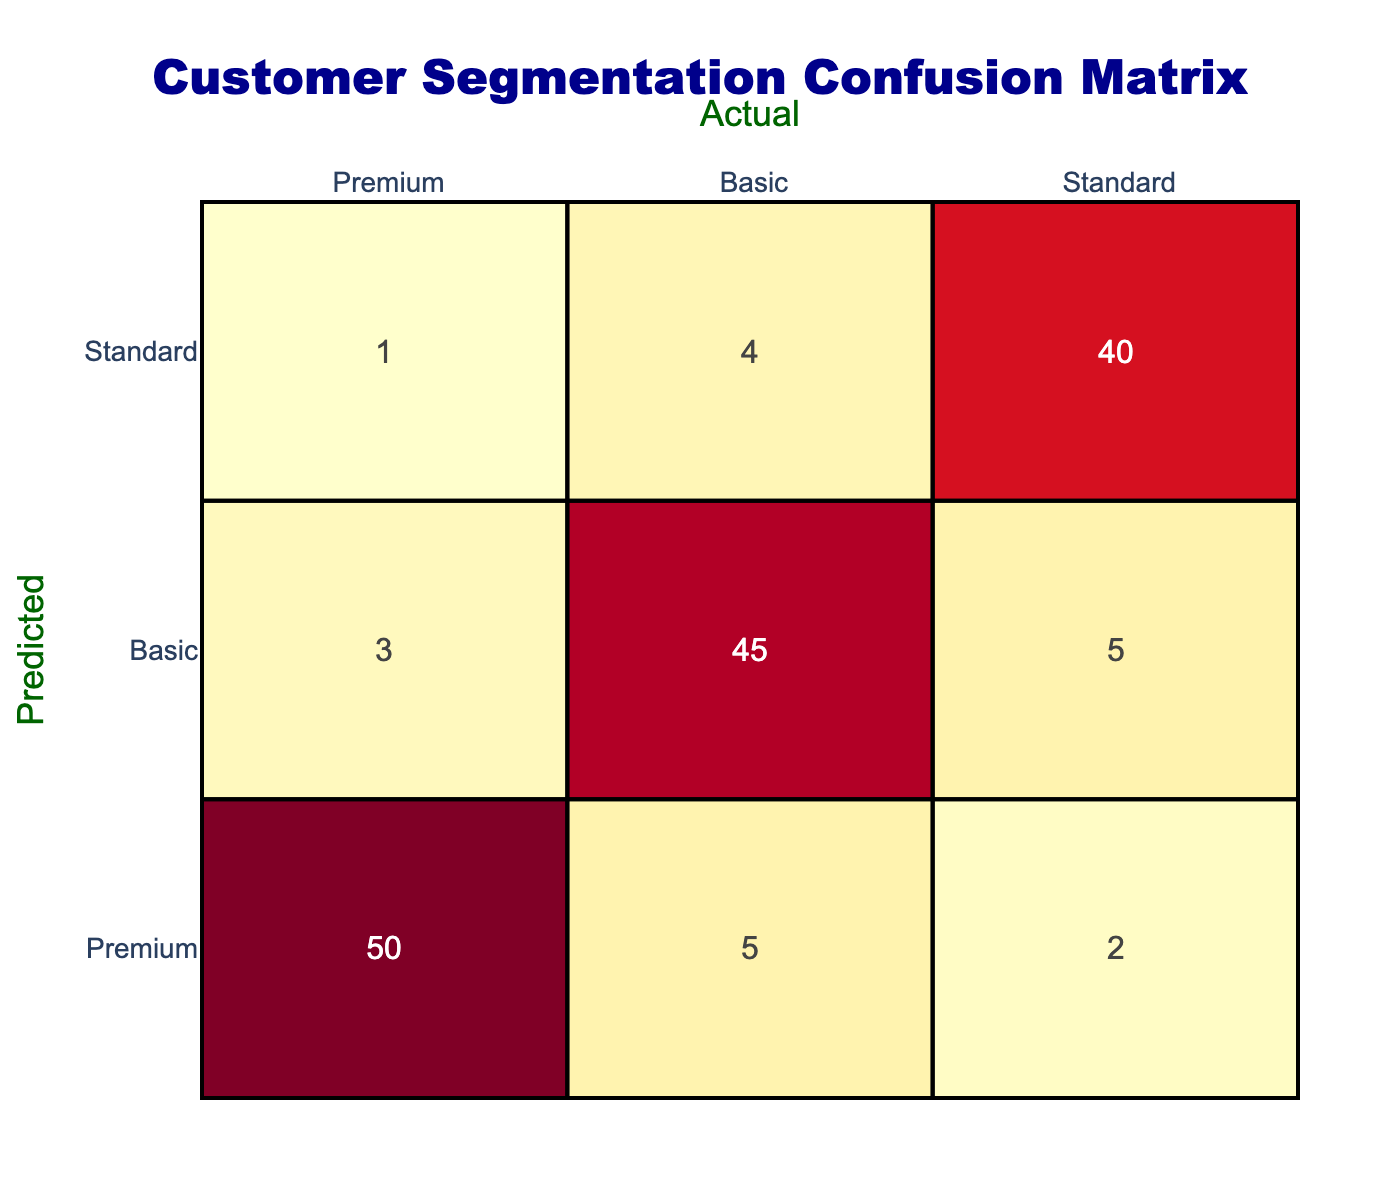What is the number of predictions for the Premium segment? To find the number of predictions for the Premium segment, I look at the row labeled 'Premium' in the table. The corresponding values are 50 (true positives), 5 (false negatives), and 2 (false positives). The total predictions for Premium can be calculated as 50 + 5 + 2 = 57.
Answer: 57 What is the total number of Basic predictions? I check the row labeled 'Basic' in the table. The values there are 3 (false positives), 45 (true positives), and 5 (false negatives). The sum of these values gives the total for Basic: 3 + 45 + 5 = 53.
Answer: 53 How many predictions were made for the Standard segment that were actually Basic? I need to find the value in the Standard row under the Basic column. Referring to the table, this value is 4, indicating that 4 predictions mistakenly classified Standard customers as Basic.
Answer: 4 What is the accuracy for the Premium segment? The accuracy for the Premium segment is calculated by taking the number of true predictions for Premium (50) and dividing it by the total predictions for Premium (57). So, accuracy = 50 / 57 = approximately 0.877 or 87.7%.
Answer: 87.7% Is the number of false negatives for the Standard segment greater than the false positives for the Basic segment? I check the table and find that the false negatives for Standard are 4, and the false positives for Basic are 3. Since 4 is greater than 3, the answer is yes.
Answer: Yes What is the total number of correct predictions across all segments? To find the total number of correct predictions, I add all true positives: 50 (Premium) + 45 (Basic) + 40 (Standard) = 135.
Answer: 135 What percentage of Basic predictions were false? First, I find the total predictions for Basic, which is 53. The false predictions are the sum of false positives (3) and false negatives (5), giving a total of 8. The percentage of false predictions is (8 / 53) * 100 ≈ 15.09%.
Answer: 15.09% How many times were Basic segment predictions misclassified as Premium? I look at the Basic row in the Premium column, which shows the value 3. This indicates that 3 Basic segment predictions were misclassified as Premium.
Answer: 3 What is the overall misclassification rate for Standard segment predictions? To calculate the misclassification rate, I first find the total predictions for Standard (1 + 4 + 40 = 45). Then I examine how many were incorrect: false positives (1) + false negatives (4) = 5. The misclassification rate is (5 / 45) * 100 ≈ 11.11%.
Answer: 11.11% 